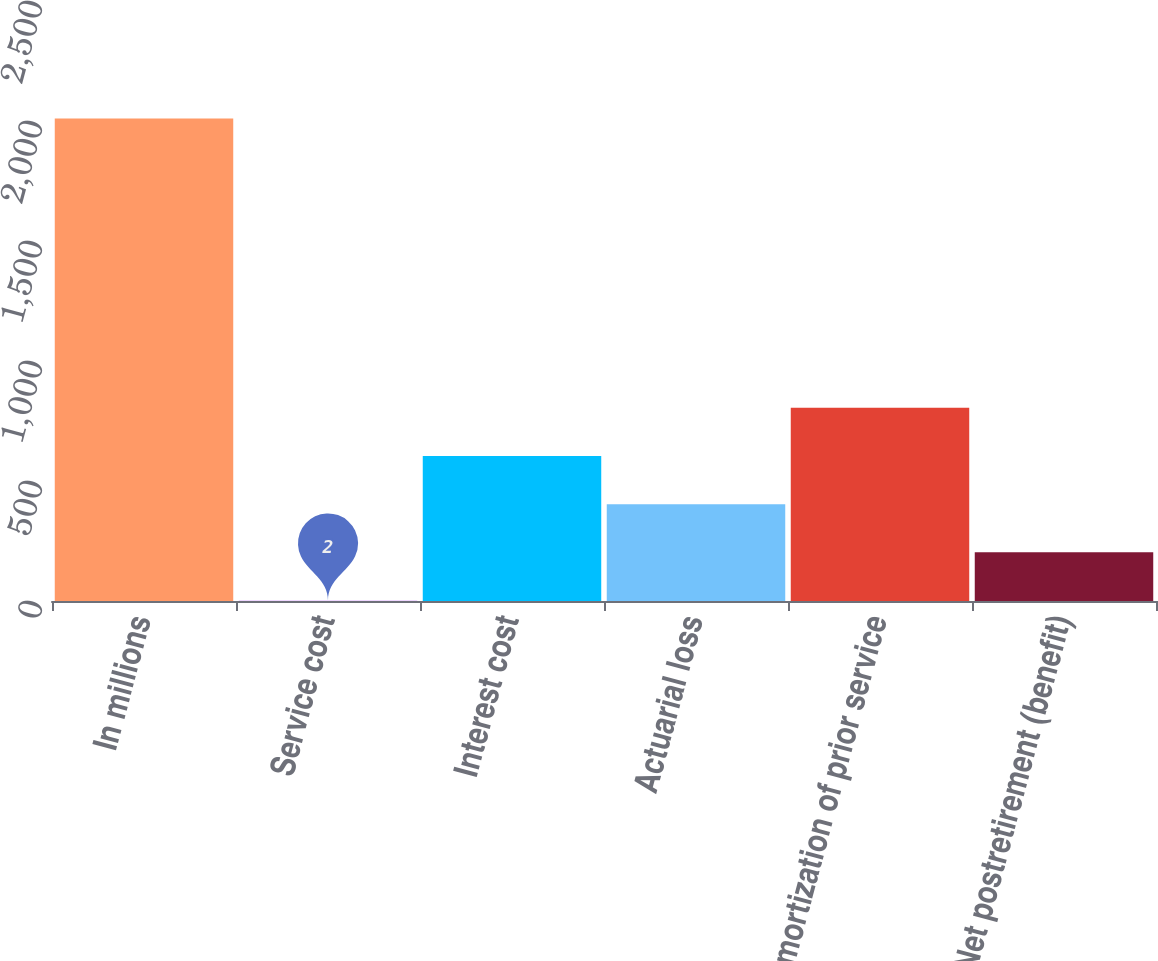<chart> <loc_0><loc_0><loc_500><loc_500><bar_chart><fcel>In millions<fcel>Service cost<fcel>Interest cost<fcel>Actuarial loss<fcel>Amortization of prior service<fcel>Net postretirement (benefit)<nl><fcel>2010<fcel>2<fcel>604.4<fcel>403.6<fcel>805.2<fcel>202.8<nl></chart> 